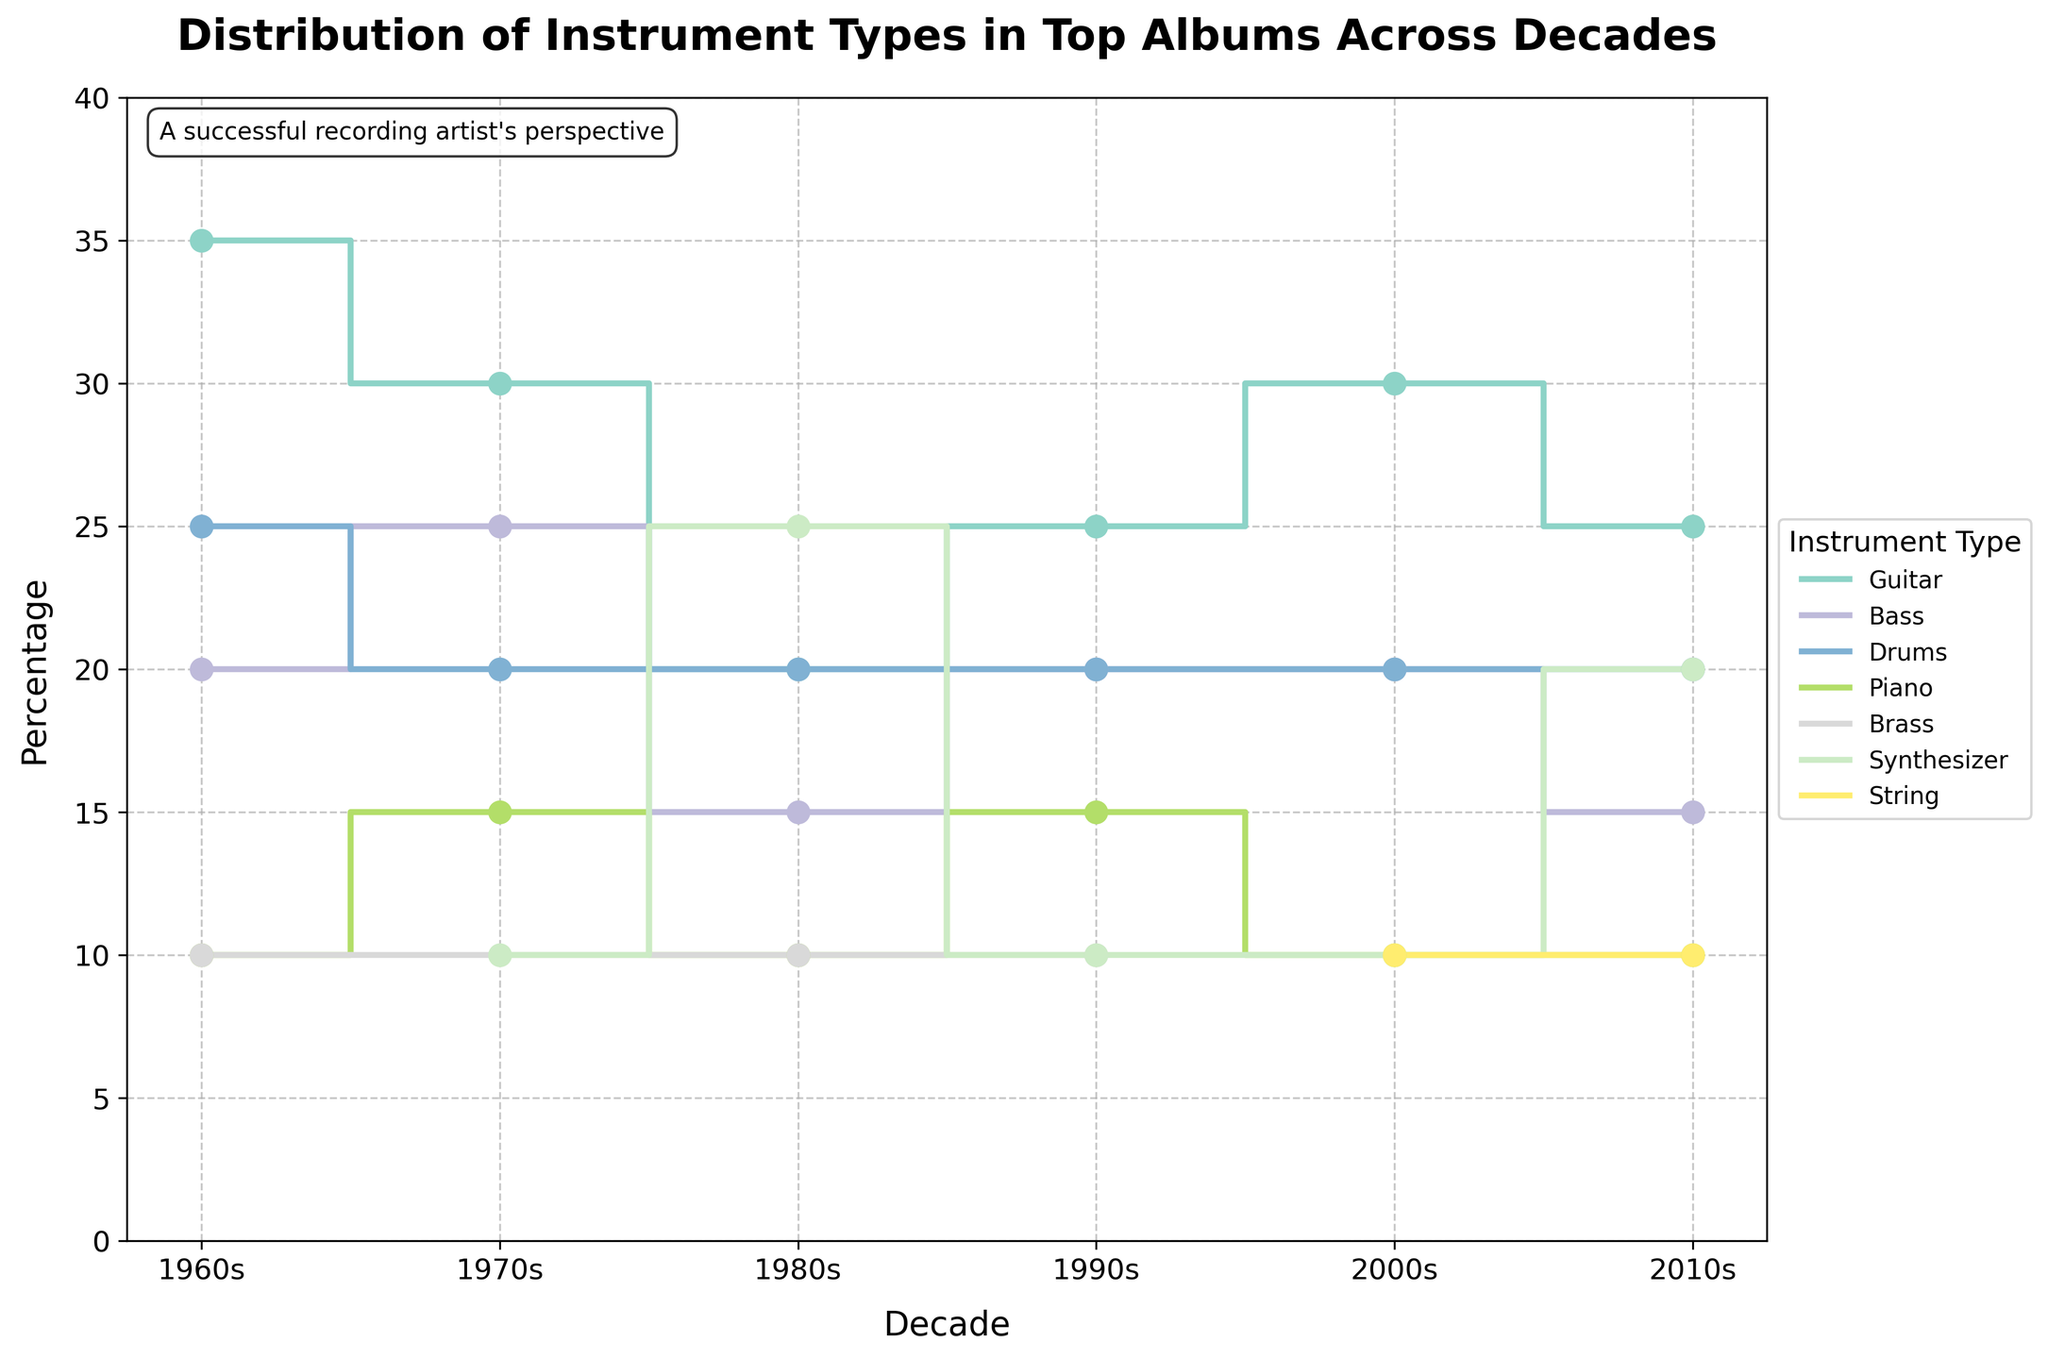what is the title of the figure? The title of the figure is displayed at the top in bold font. It summarizes what the figure is showing.
Answer: Distribution of Instrument Types in Top Albums Across Decades what is the percentage of guitar usage in the 2000s? Locate the '2000s' on the x-axis and follow the data point associated with 'Guitar.' Check the y-axis to find the corresponding percentage.
Answer: 30% which instrument type shows the most significant increase in percentage from the 1960s to the 1980s? Compare the percentages for each instrument type in the 1960s and the 1980s. Calculate the difference for each, and identify the instrument with the largest positive change.
Answer: Synthesizer what is the average percentage of piano usage across all decades? Sum the percentages of 'Piano' for each decade and divide by the number of decades. (10 + 15 + 10 + 15 + 10 + 10 + 10) / 6 = 70 / 6 = 11.67.
Answer: 11.67% in which decade did bass have the highest usage percentage? Examine the data points for 'Bass' in each decade and identify the maximum value on the y-axis.
Answer: 1970s compare the usage of drums in the 1980s and 2010s. which decade has a higher percentage? Locate the 'Drums' percentage for the 1980s and 2010s on the y-axis, and compare the two.
Answer: Equal at 20% what instrument is introduced in the 2000s? Look at the legend and identify any new instrument type that appears starting from the 2000s.
Answer: String which decade shows the least variety in instrument types? Count the number of unique instrument types for each decade and identify the decade with the fewest types.
Answer: 1960s how does the usage of synthesizers change between the 1980s and 2010s? Locate the percentage values for 'Synthesizer' in the 1980s and 2010s and observe the difference on the y-axis.
Answer: Increase from 25% to 20% what is the combined percentage of brass and strings in the 2010s? Sum the percentage values for 'Brass' and 'Strings' in the 2010s. (10 + 10) = 20.
Answer: 20% 